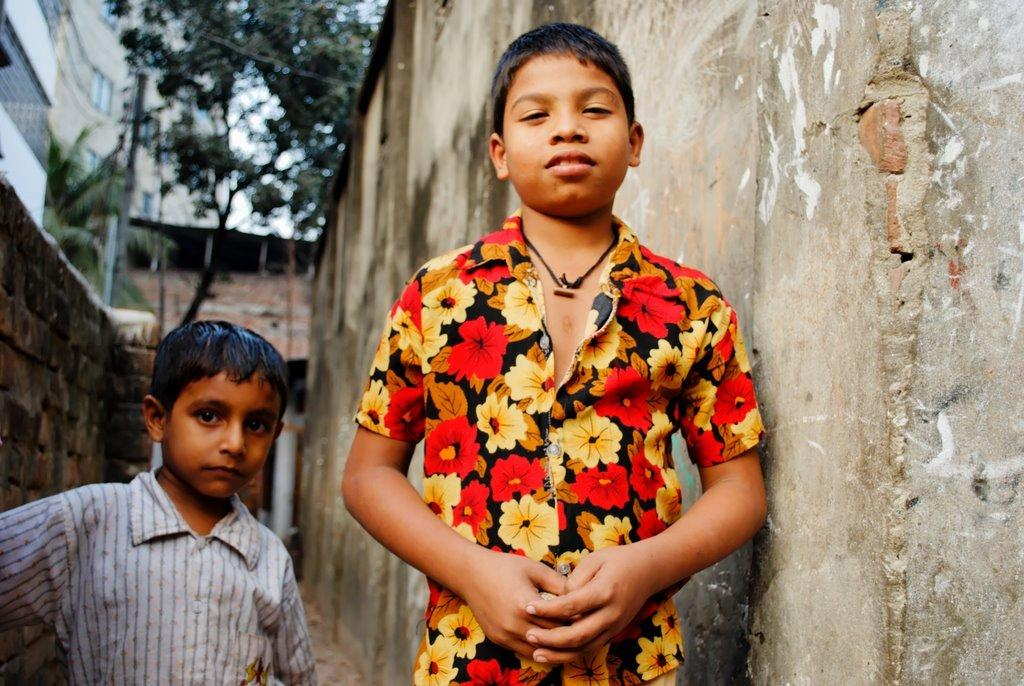How many children are present in the image? There are two children standing in the image. What can be seen in the background of the image? There is a building and a tree in the image. What type of coal is being used to generate heat in the image? There is no coal or heat source present in the image. 